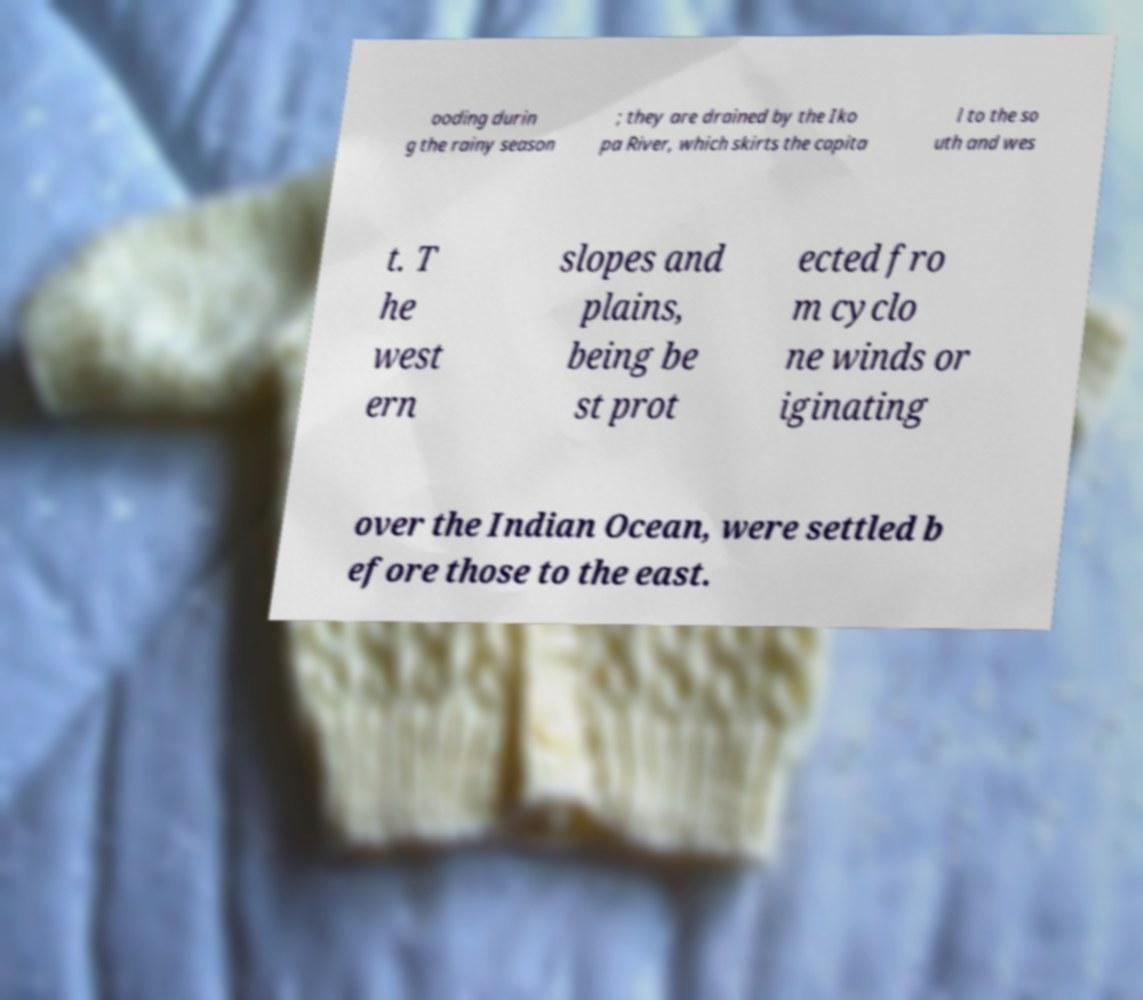Can you accurately transcribe the text from the provided image for me? ooding durin g the rainy season ; they are drained by the Iko pa River, which skirts the capita l to the so uth and wes t. T he west ern slopes and plains, being be st prot ected fro m cyclo ne winds or iginating over the Indian Ocean, were settled b efore those to the east. 